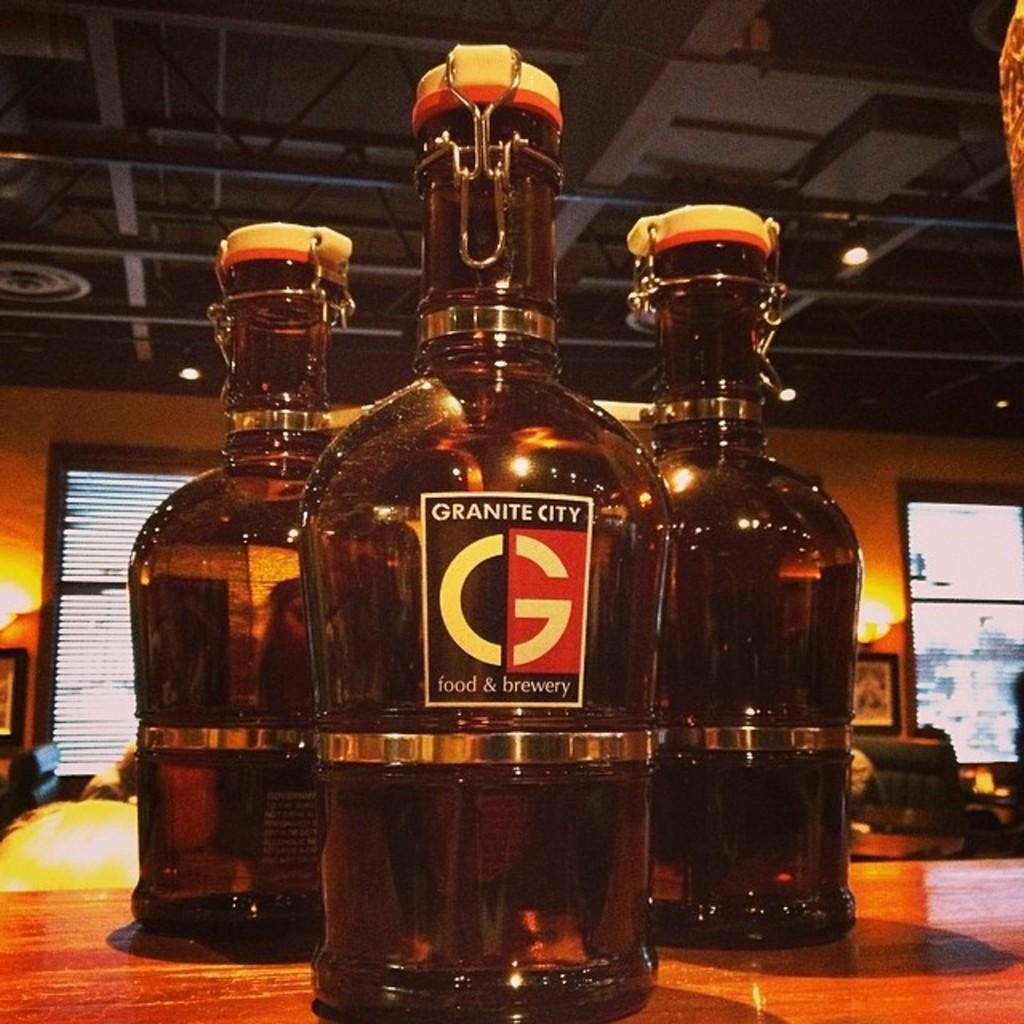<image>
Provide a brief description of the given image. The growler is from the restaurant Granite City 